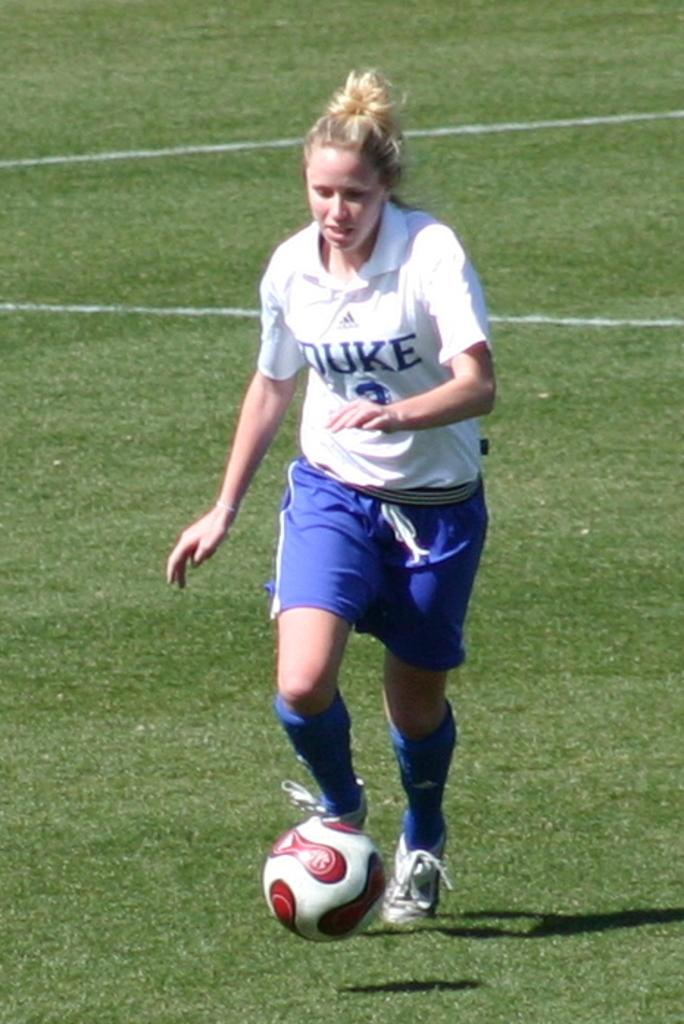Who is the main subject in the image? There is a woman in the image. What is the woman doing in the image? The woman is playing football. Where is the football being played in the image? The football is being played in a ground. What type of bed is visible in the image? A: There is no bed present in the image; it features a woman playing football in a ground. 